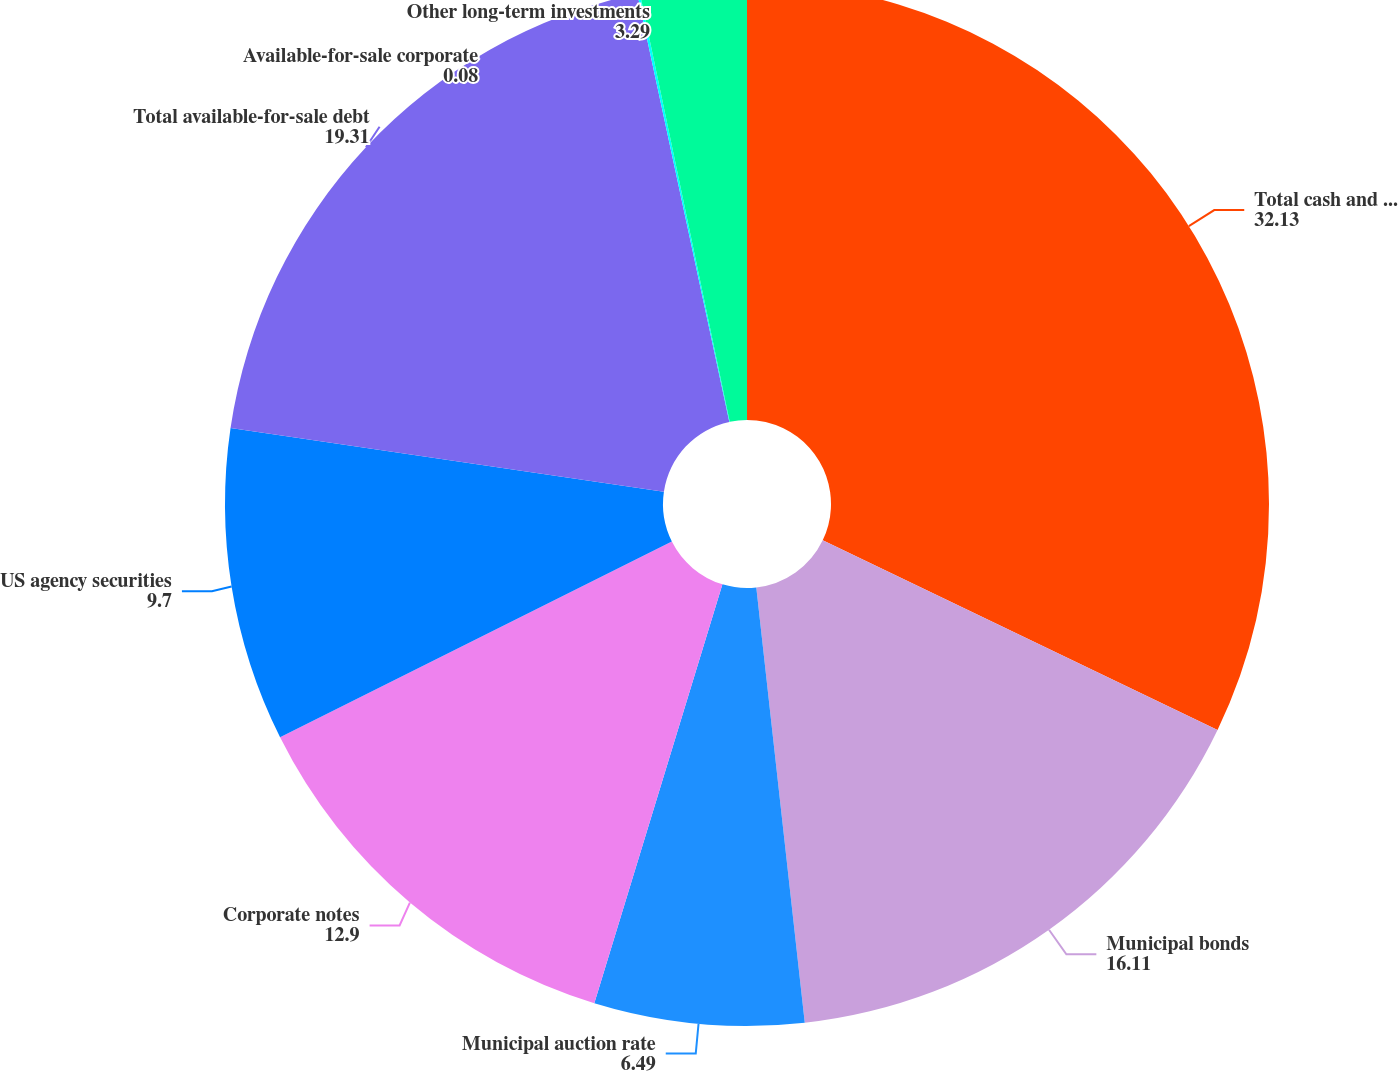Convert chart. <chart><loc_0><loc_0><loc_500><loc_500><pie_chart><fcel>Total cash and cash<fcel>Municipal bonds<fcel>Municipal auction rate<fcel>Corporate notes<fcel>US agency securities<fcel>Total available-for-sale debt<fcel>Available-for-sale corporate<fcel>Other long-term investments<nl><fcel>32.13%<fcel>16.11%<fcel>6.49%<fcel>12.9%<fcel>9.7%<fcel>19.31%<fcel>0.08%<fcel>3.29%<nl></chart> 